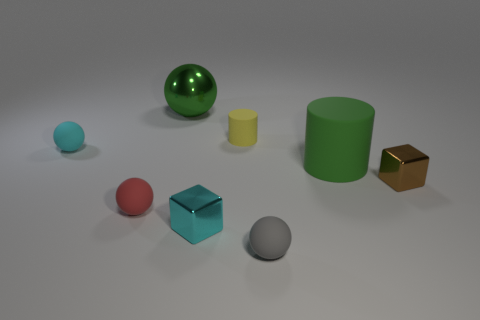Can you guess what materials these objects might be made from? Based on their appearances, the blue sphere and green cylinder might be made of rubber due to their matte finish. The shiny sphere seems metallic, possibly steel, whereas the cube looks like it could be made of gold or a gold-like material due to its luster.  Which object stands out the most to you? The glossy golden cube stands out due to its reflective surface and distinctive color, making it a sharp contrast against the muted tones of the other items. 